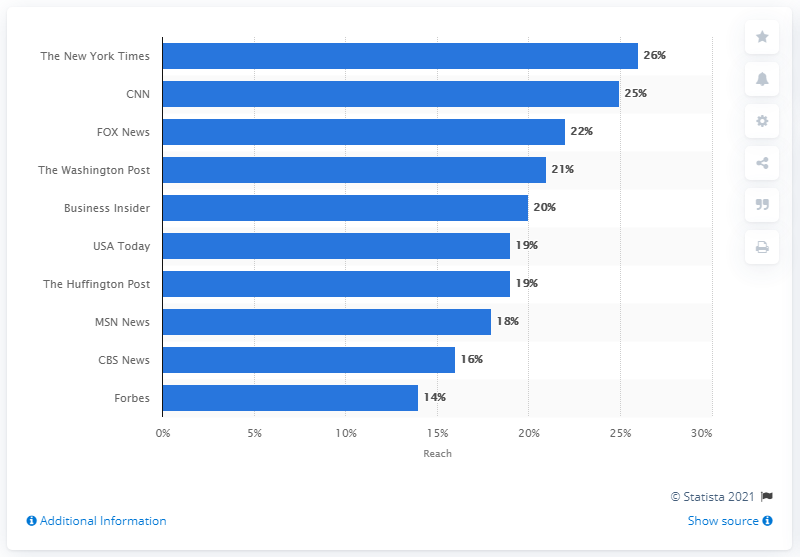Specify some key components in this picture. The New York Times was the most popular news brand in the United States as of June 2018. 